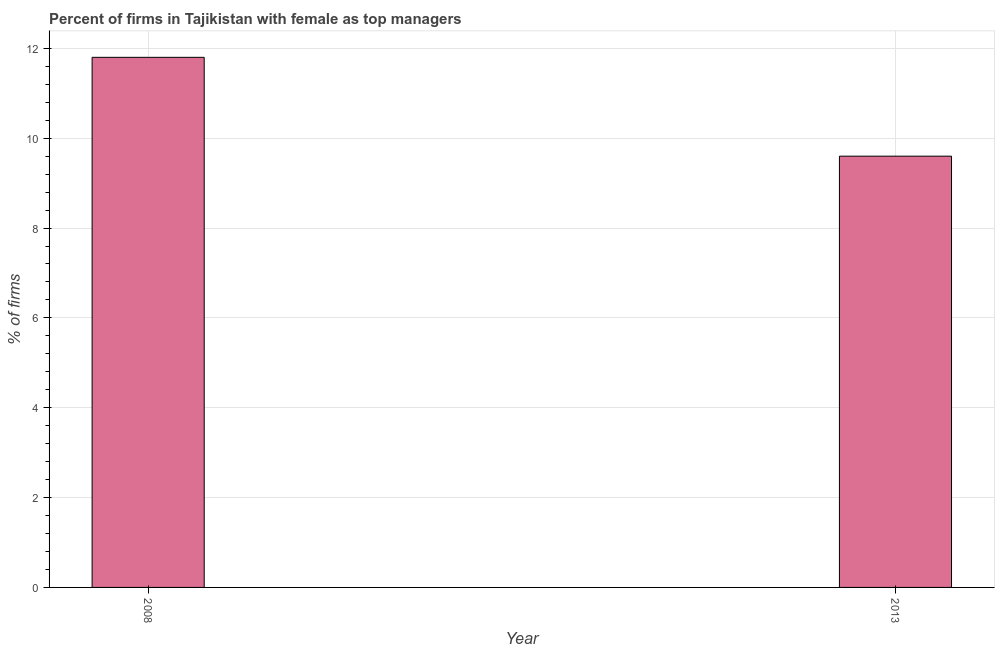Does the graph contain any zero values?
Offer a terse response. No. Does the graph contain grids?
Ensure brevity in your answer.  Yes. What is the title of the graph?
Provide a succinct answer. Percent of firms in Tajikistan with female as top managers. What is the label or title of the X-axis?
Your answer should be very brief. Year. What is the label or title of the Y-axis?
Your answer should be very brief. % of firms. What is the percentage of firms with female as top manager in 2013?
Ensure brevity in your answer.  9.6. Across all years, what is the minimum percentage of firms with female as top manager?
Your answer should be very brief. 9.6. What is the sum of the percentage of firms with female as top manager?
Keep it short and to the point. 21.4. Do a majority of the years between 2008 and 2013 (inclusive) have percentage of firms with female as top manager greater than 10.4 %?
Provide a succinct answer. No. What is the ratio of the percentage of firms with female as top manager in 2008 to that in 2013?
Your answer should be very brief. 1.23. Is the percentage of firms with female as top manager in 2008 less than that in 2013?
Provide a short and direct response. No. How many bars are there?
Offer a terse response. 2. Are all the bars in the graph horizontal?
Offer a terse response. No. How many years are there in the graph?
Give a very brief answer. 2. What is the difference between two consecutive major ticks on the Y-axis?
Provide a succinct answer. 2. What is the difference between the % of firms in 2008 and 2013?
Give a very brief answer. 2.2. What is the ratio of the % of firms in 2008 to that in 2013?
Your answer should be compact. 1.23. 